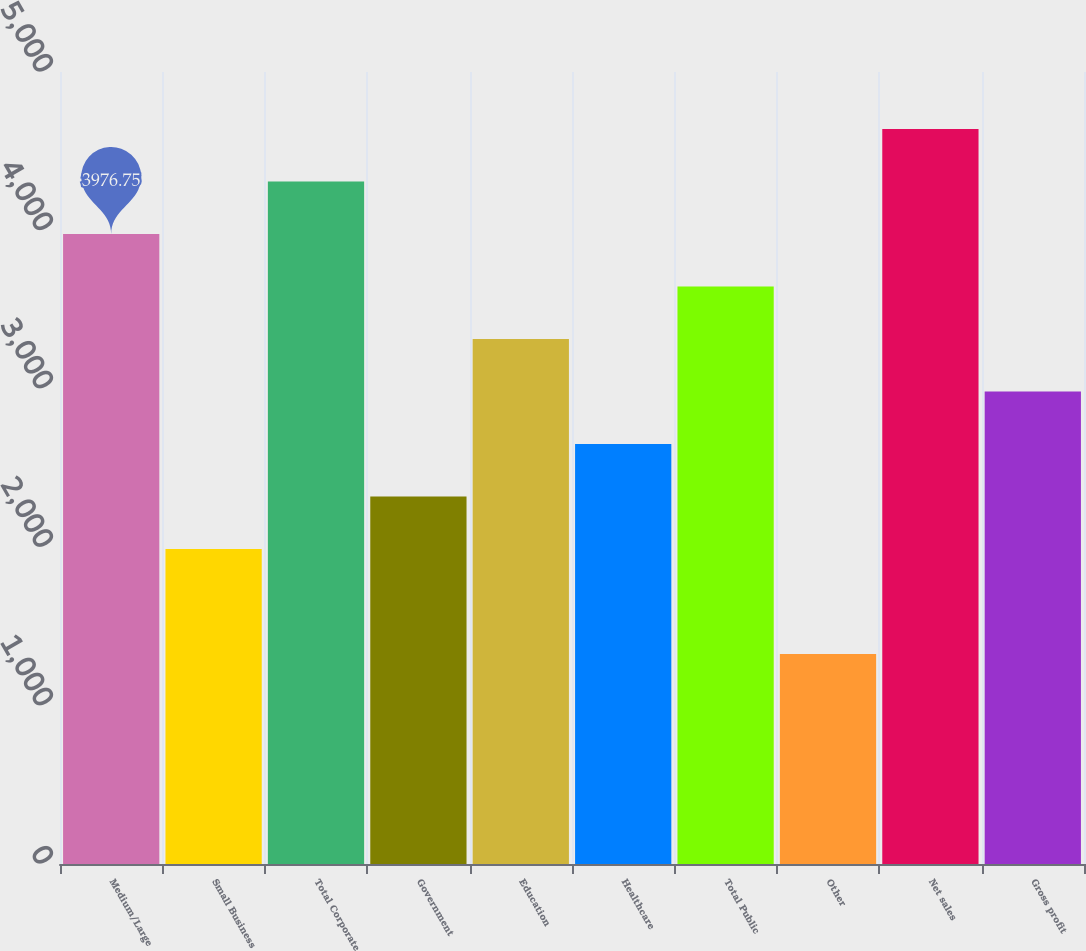Convert chart to OTSL. <chart><loc_0><loc_0><loc_500><loc_500><bar_chart><fcel>Medium/Large<fcel>Small Business<fcel>Total Corporate<fcel>Government<fcel>Education<fcel>Healthcare<fcel>Total Public<fcel>Other<fcel>Net sales<fcel>Gross profit<nl><fcel>3976.75<fcel>1988.41<fcel>4308.14<fcel>2319.8<fcel>3313.97<fcel>2651.19<fcel>3645.36<fcel>1325.63<fcel>4639.53<fcel>2982.58<nl></chart> 